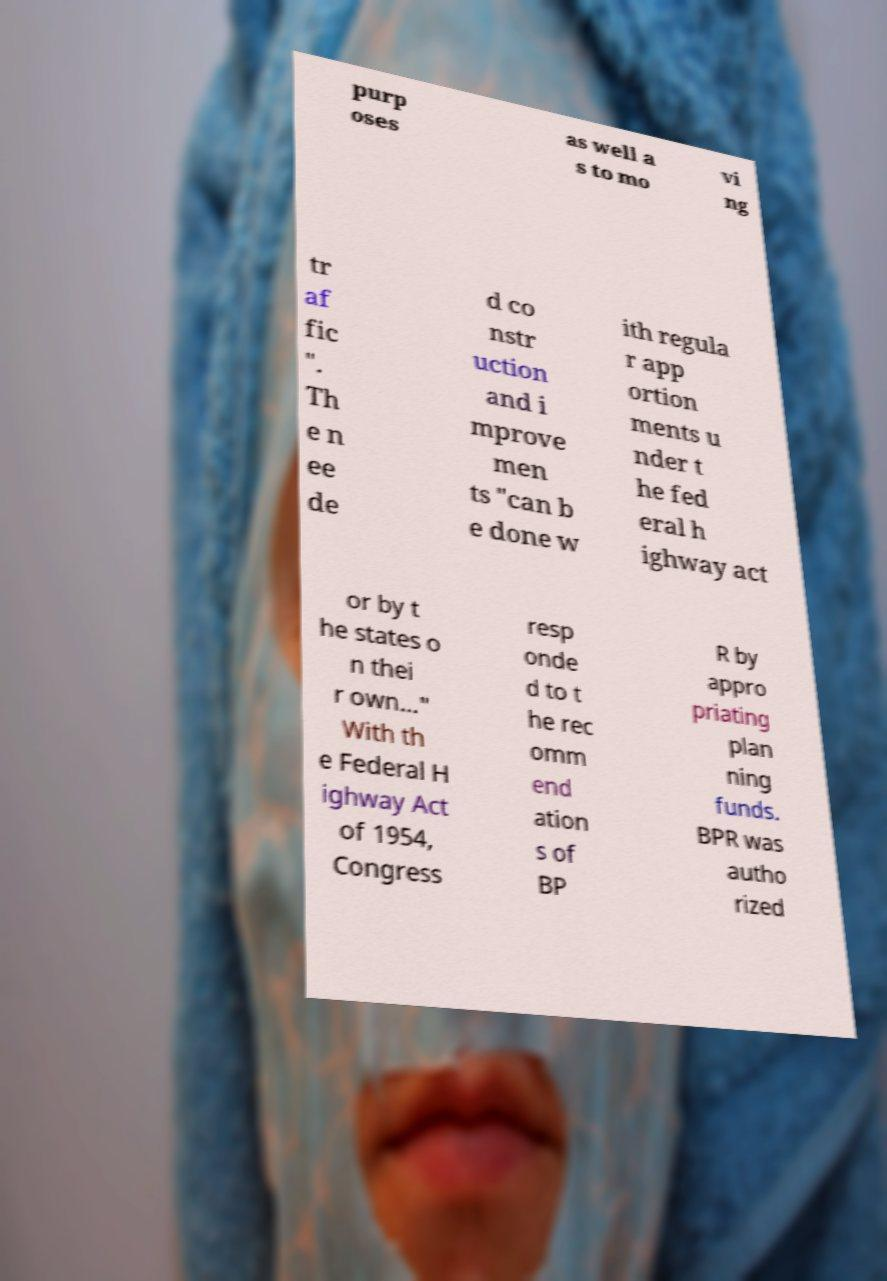What messages or text are displayed in this image? I need them in a readable, typed format. purp oses as well a s to mo vi ng tr af fic ". Th e n ee de d co nstr uction and i mprove men ts "can b e done w ith regula r app ortion ments u nder t he fed eral h ighway act or by t he states o n thei r own..." With th e Federal H ighway Act of 1954, Congress resp onde d to t he rec omm end ation s of BP R by appro priating plan ning funds. BPR was autho rized 